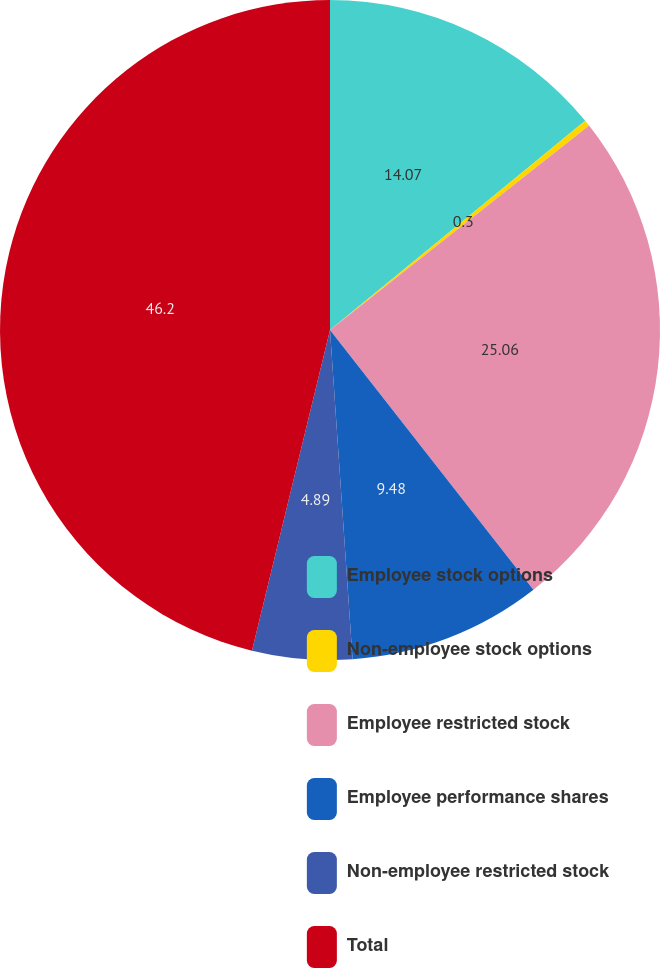Convert chart. <chart><loc_0><loc_0><loc_500><loc_500><pie_chart><fcel>Employee stock options<fcel>Non-employee stock options<fcel>Employee restricted stock<fcel>Employee performance shares<fcel>Non-employee restricted stock<fcel>Total<nl><fcel>14.07%<fcel>0.3%<fcel>25.06%<fcel>9.48%<fcel>4.89%<fcel>46.2%<nl></chart> 